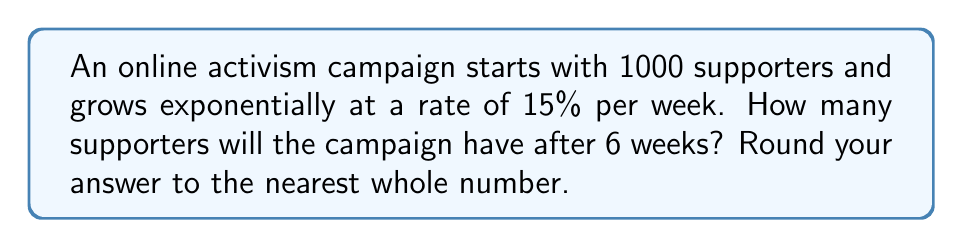Can you solve this math problem? Let's approach this step-by-step using an exponential function:

1) The general form of an exponential growth function is:
   $A(t) = A_0 \cdot (1 + r)^t$

   Where:
   $A(t)$ is the amount after time $t$
   $A_0$ is the initial amount
   $r$ is the growth rate (as a decimal)
   $t$ is the time period

2) In this case:
   $A_0 = 1000$ (initial supporters)
   $r = 0.15$ (15% growth rate)
   $t = 6$ (weeks)

3) Plugging these values into our equation:
   $A(6) = 1000 \cdot (1 + 0.15)^6$

4) Simplify:
   $A(6) = 1000 \cdot (1.15)^6$

5) Calculate:
   $A(6) = 1000 \cdot 2.3131442...$ 
   $A(6) = 2313.1442...$

6) Rounding to the nearest whole number:
   $A(6) \approx 2313$

Therefore, after 6 weeks, the campaign will have approximately 2313 supporters.
Answer: 2313 supporters 